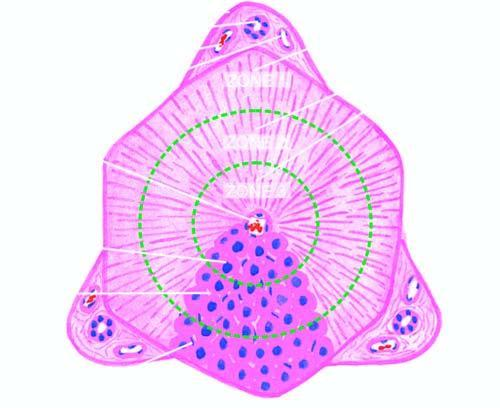what are the functional divisions of the lobule into 3 zones shown by?
Answer the question using a single word or phrase. Circles 